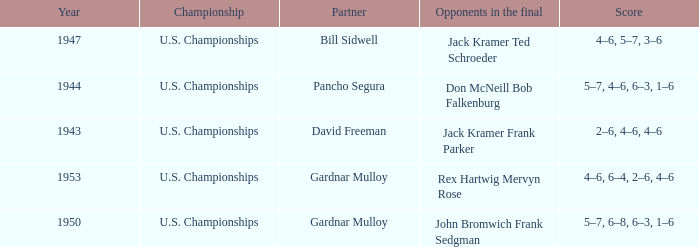Which Opponents in the final have a Score of 4–6, 6–4, 2–6, 4–6? Rex Hartwig Mervyn Rose. 